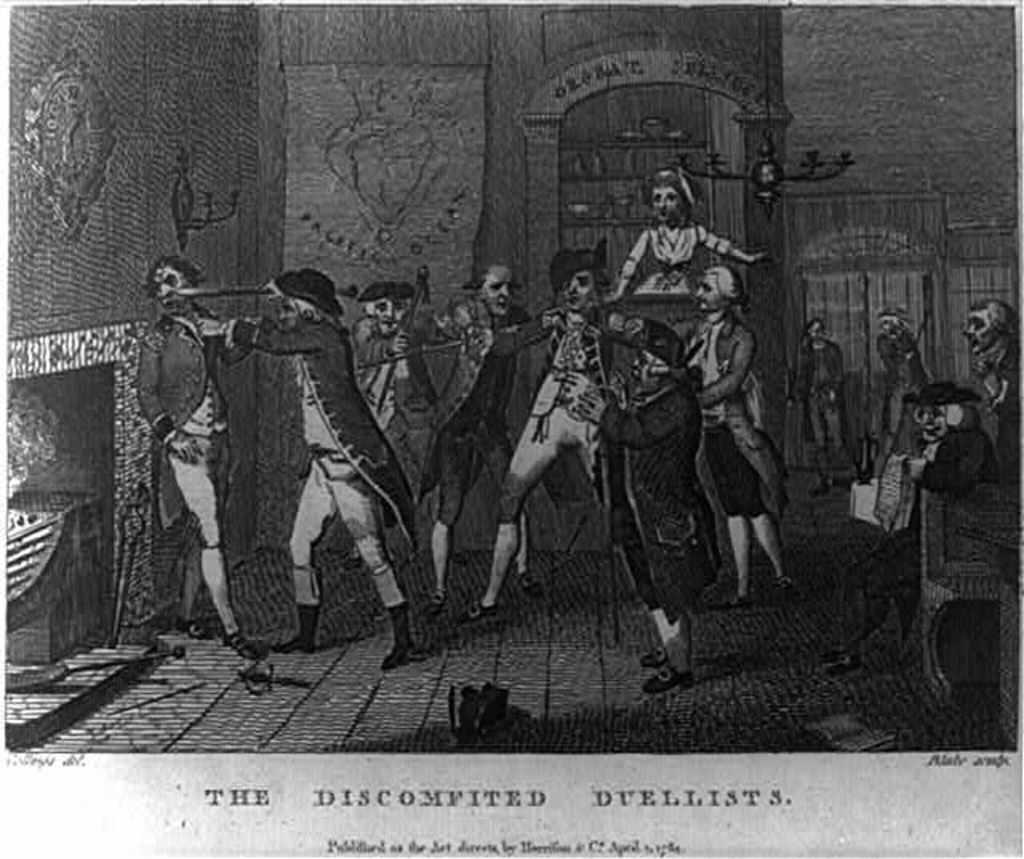What is the main subject of the image? There is a poster in the image. What is shown on the poster? People are depicted on the poster. Is there any text present in the image? Yes, there is text at the bottom of the image. What advice does the uncle give on the poster in the image? There is no uncle or advice present on the poster in the image; it only depicts people and has text at the bottom. 